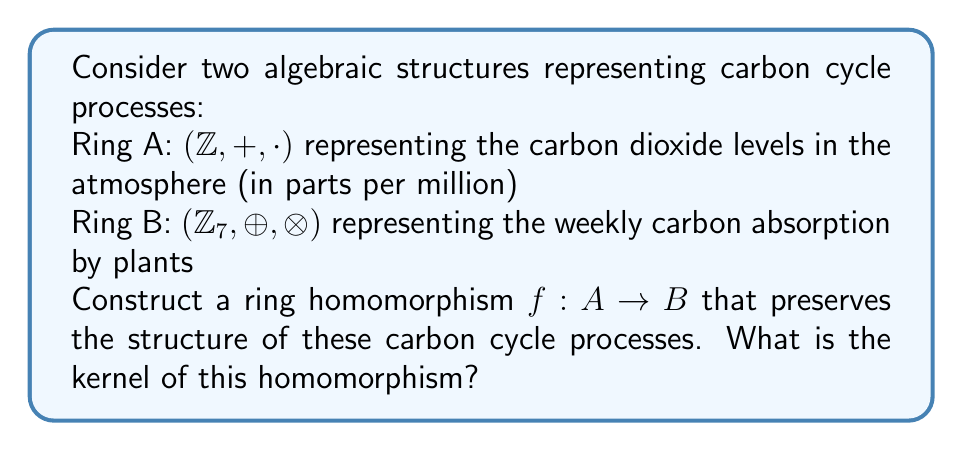What is the answer to this math problem? To construct a ring homomorphism $f: A \to B$, we need to define a function that preserves both addition and multiplication operations while mapping elements from Ring A to Ring B. Let's approach this step-by-step:

1) First, recall that a ring homomorphism $f: A \to B$ must satisfy:
   a) $f(a + b) = f(a) \oplus f(b)$ for all $a, b \in A$
   b) $f(a \cdot b) = f(a) \otimes f(b)$ for all $a, b \in A$
   c) $f(1_A) = 1_B$

2) Given that B is $\mathbb{Z}_7$, we need a function that maps integers to their equivalence classes modulo 7.

3) A natural choice for $f$ would be:
   $f(n) = [n]_7$ for all $n \in \mathbb{Z}$

4) Let's verify that this is indeed a ring homomorphism:
   a) $f(a + b) = [a + b]_7 = [a]_7 \oplus [b]_7 = f(a) \oplus f(b)$
   b) $f(a \cdot b) = [a \cdot b]_7 = [a]_7 \otimes [b]_7 = f(a) \otimes f(b)$
   c) $f(1) = [1]_7 = 1_B$

5) Now that we have confirmed $f$ is a ring homomorphism, let's find its kernel.

6) The kernel of a ring homomorphism is the set of all elements in the domain that map to the zero element in the codomain:
   $\text{ker}(f) = \{a \in A | f(a) = 0_B\}$

7) In this case, $\text{ker}(f) = \{a \in \mathbb{Z} | [a]_7 = [0]_7\}$

8) This is equivalent to all integers divisible by 7:
   $\text{ker}(f) = \{7k | k \in \mathbb{Z}\} = 7\mathbb{Z}$

This homomorphism can be interpreted as mapping the continuous process of carbon dioxide accumulation in the atmosphere to a cyclic process of weekly plant absorption, highlighting the repetitive nature of carbon absorption in the natural cycle.
Answer: The kernel of the homomorphism $f: A \to B$ defined by $f(n) = [n]_7$ is $\text{ker}(f) = 7\mathbb{Z}$. 